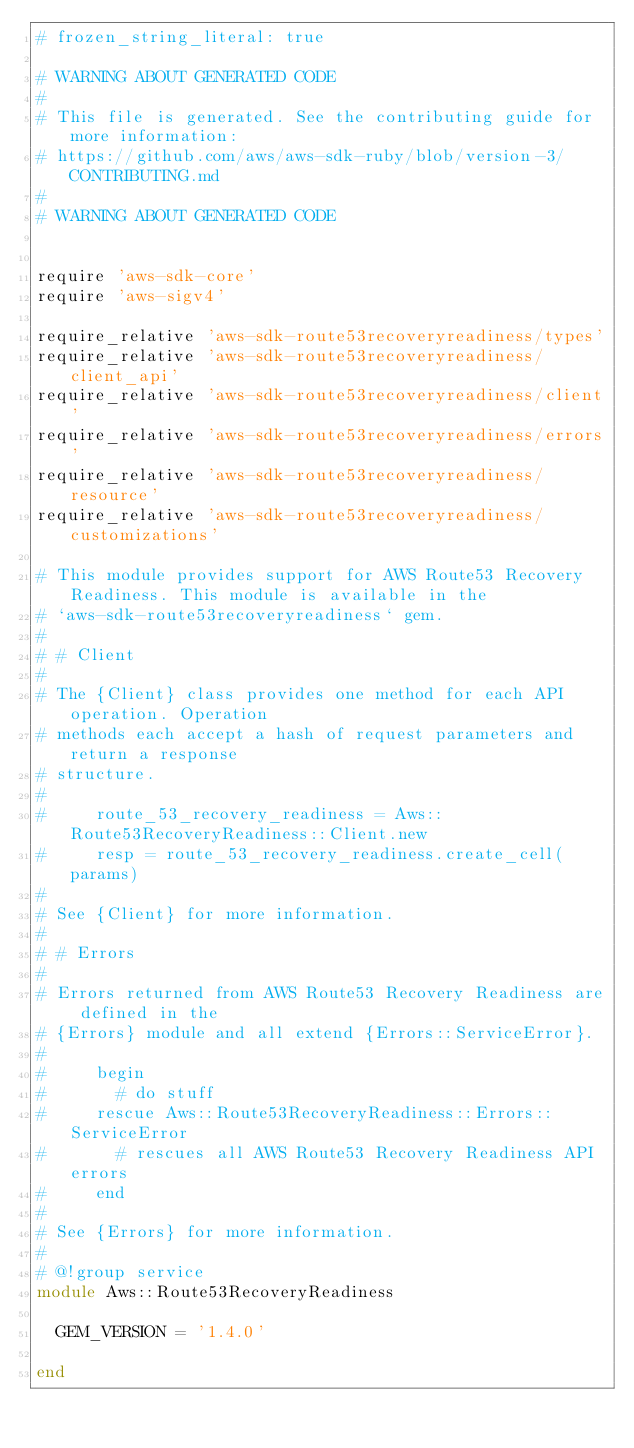Convert code to text. <code><loc_0><loc_0><loc_500><loc_500><_Ruby_># frozen_string_literal: true

# WARNING ABOUT GENERATED CODE
#
# This file is generated. See the contributing guide for more information:
# https://github.com/aws/aws-sdk-ruby/blob/version-3/CONTRIBUTING.md
#
# WARNING ABOUT GENERATED CODE


require 'aws-sdk-core'
require 'aws-sigv4'

require_relative 'aws-sdk-route53recoveryreadiness/types'
require_relative 'aws-sdk-route53recoveryreadiness/client_api'
require_relative 'aws-sdk-route53recoveryreadiness/client'
require_relative 'aws-sdk-route53recoveryreadiness/errors'
require_relative 'aws-sdk-route53recoveryreadiness/resource'
require_relative 'aws-sdk-route53recoveryreadiness/customizations'

# This module provides support for AWS Route53 Recovery Readiness. This module is available in the
# `aws-sdk-route53recoveryreadiness` gem.
#
# # Client
#
# The {Client} class provides one method for each API operation. Operation
# methods each accept a hash of request parameters and return a response
# structure.
#
#     route_53_recovery_readiness = Aws::Route53RecoveryReadiness::Client.new
#     resp = route_53_recovery_readiness.create_cell(params)
#
# See {Client} for more information.
#
# # Errors
#
# Errors returned from AWS Route53 Recovery Readiness are defined in the
# {Errors} module and all extend {Errors::ServiceError}.
#
#     begin
#       # do stuff
#     rescue Aws::Route53RecoveryReadiness::Errors::ServiceError
#       # rescues all AWS Route53 Recovery Readiness API errors
#     end
#
# See {Errors} for more information.
#
# @!group service
module Aws::Route53RecoveryReadiness

  GEM_VERSION = '1.4.0'

end
</code> 